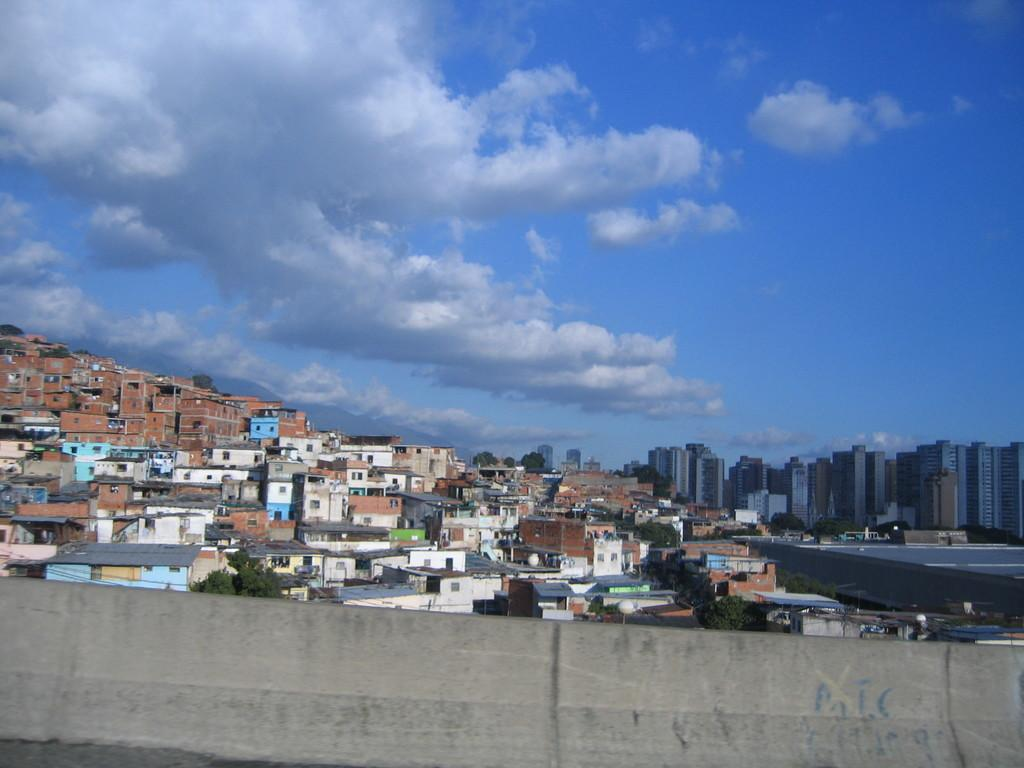What type of structure is present in the image? There is a fence wall in the image. What can be seen in the distance behind the fence wall? There are buildings and trees in the background of the image. What part of the natural environment is visible in the image? The sky is visible in the image. How would you describe the weather based on the appearance of the sky? The sky appears to be cloudy in the image. Where is the aunt standing in the image? There is no aunt present in the image. What type of performance is happening on the stage in the image? There is no stage present in the image. 